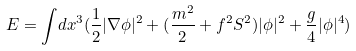Convert formula to latex. <formula><loc_0><loc_0><loc_500><loc_500>E = { \int } d x ^ { 3 } ( \frac { 1 } { 2 } | { \nabla } { \phi } | ^ { 2 } + ( \frac { { m } ^ { 2 } } { 2 } + f ^ { 2 } S ^ { 2 } ) | { \phi } | ^ { 2 } + \frac { g } { 4 } | { \phi } | ^ { 4 } )</formula> 